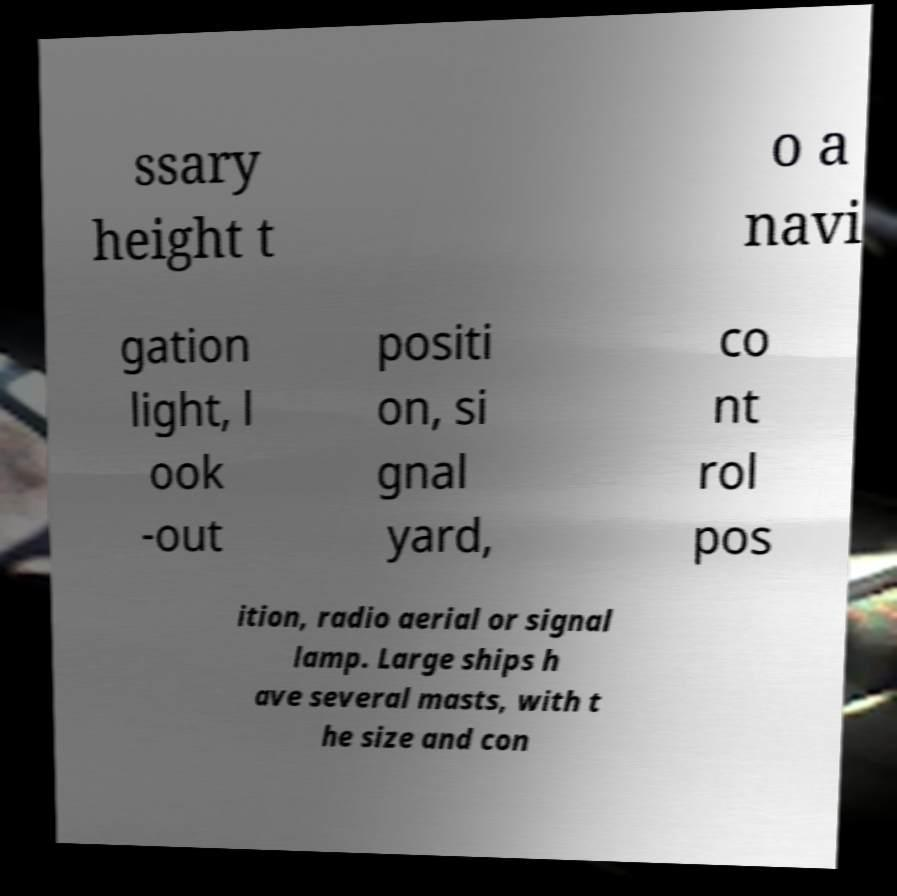Could you extract and type out the text from this image? ssary height t o a navi gation light, l ook -out positi on, si gnal yard, co nt rol pos ition, radio aerial or signal lamp. Large ships h ave several masts, with t he size and con 